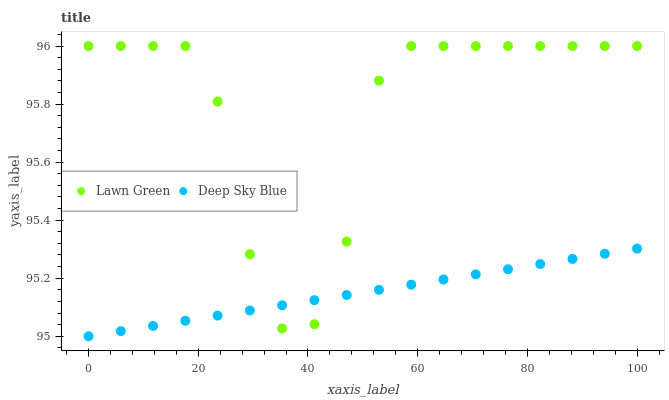Does Deep Sky Blue have the minimum area under the curve?
Answer yes or no. Yes. Does Lawn Green have the maximum area under the curve?
Answer yes or no. Yes. Does Deep Sky Blue have the maximum area under the curve?
Answer yes or no. No. Is Deep Sky Blue the smoothest?
Answer yes or no. Yes. Is Lawn Green the roughest?
Answer yes or no. Yes. Is Deep Sky Blue the roughest?
Answer yes or no. No. Does Deep Sky Blue have the lowest value?
Answer yes or no. Yes. Does Lawn Green have the highest value?
Answer yes or no. Yes. Does Deep Sky Blue have the highest value?
Answer yes or no. No. Does Lawn Green intersect Deep Sky Blue?
Answer yes or no. Yes. Is Lawn Green less than Deep Sky Blue?
Answer yes or no. No. Is Lawn Green greater than Deep Sky Blue?
Answer yes or no. No. 